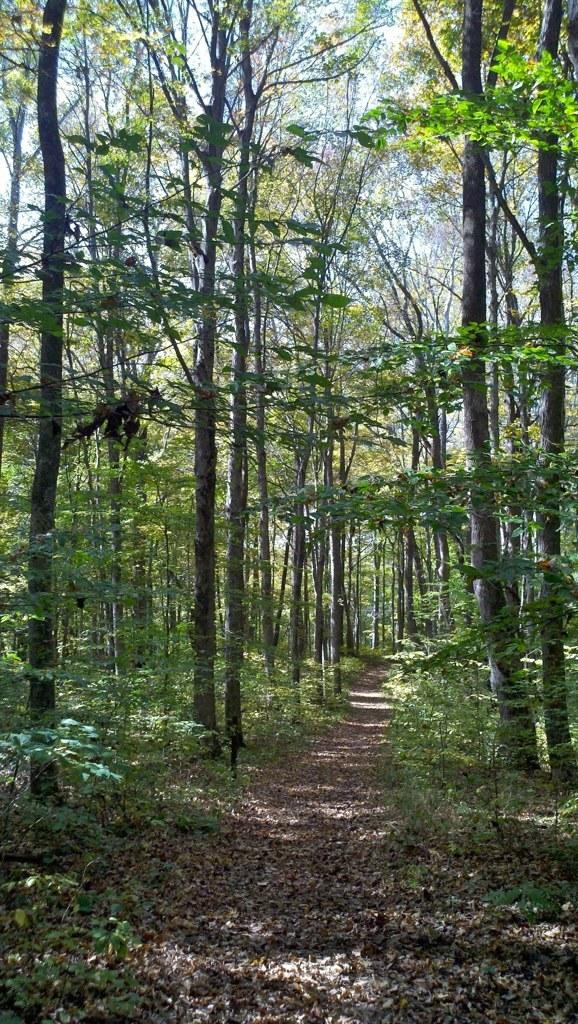What is on the ground in the image? There are dried leaves on the ground in the image. What type of vegetation is present in the image? There are trees in the image. What can be seen in the background of the image? The sky is visible in the background of the image. What type of cushion is being used to express anger in the image? There is no cushion or expression of anger present in the image. 